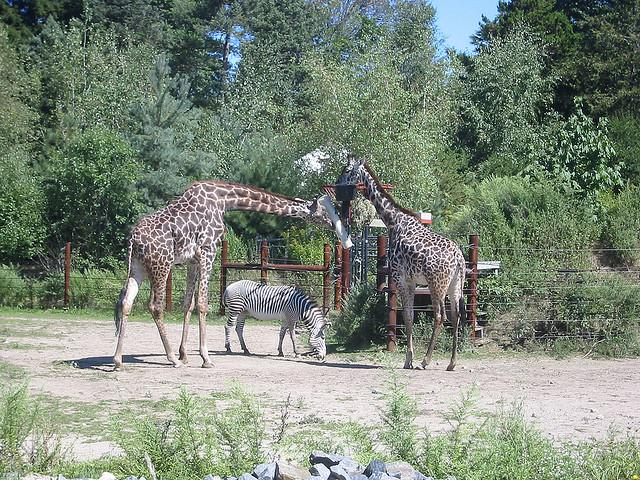What animal is between the giraffes?

Choices:
A) cat
B) zebra
C) cow
D) dog zebra 